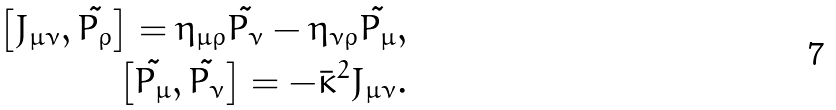<formula> <loc_0><loc_0><loc_500><loc_500>\left [ J _ { \mu \nu } , \tilde { P _ { \rho } } \right ] = \eta _ { \mu \rho } \tilde { P _ { \nu } } - \eta _ { \nu \rho } \tilde { P _ { \mu } } , \\ \left [ \tilde { P _ { \mu } } , \tilde { P _ { \nu } } \right ] = - \bar { \kappa } ^ { 2 } J _ { \mu \nu } .</formula> 